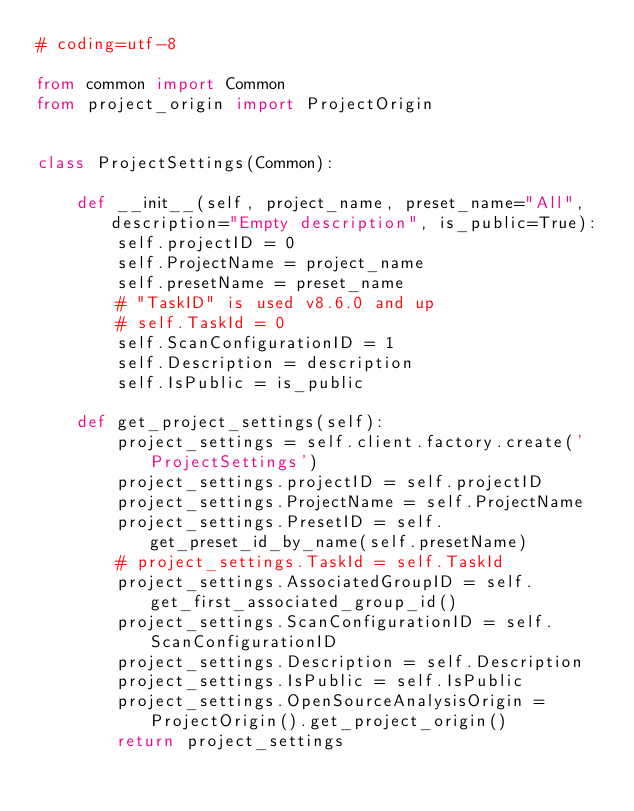<code> <loc_0><loc_0><loc_500><loc_500><_Python_># coding=utf-8

from common import Common
from project_origin import ProjectOrigin


class ProjectSettings(Common):

    def __init__(self, project_name, preset_name="All", description="Empty description", is_public=True):
        self.projectID = 0
        self.ProjectName = project_name
        self.presetName = preset_name
        # "TaskID" is used v8.6.0 and up
        # self.TaskId = 0
        self.ScanConfigurationID = 1
        self.Description = description
        self.IsPublic = is_public

    def get_project_settings(self):
        project_settings = self.client.factory.create('ProjectSettings')
        project_settings.projectID = self.projectID
        project_settings.ProjectName = self.ProjectName
        project_settings.PresetID = self.get_preset_id_by_name(self.presetName)
        # project_settings.TaskId = self.TaskId
        project_settings.AssociatedGroupID = self.get_first_associated_group_id()
        project_settings.ScanConfigurationID = self.ScanConfigurationID
        project_settings.Description = self.Description
        project_settings.IsPublic = self.IsPublic
        project_settings.OpenSourceAnalysisOrigin = ProjectOrigin().get_project_origin()
        return project_settings
</code> 